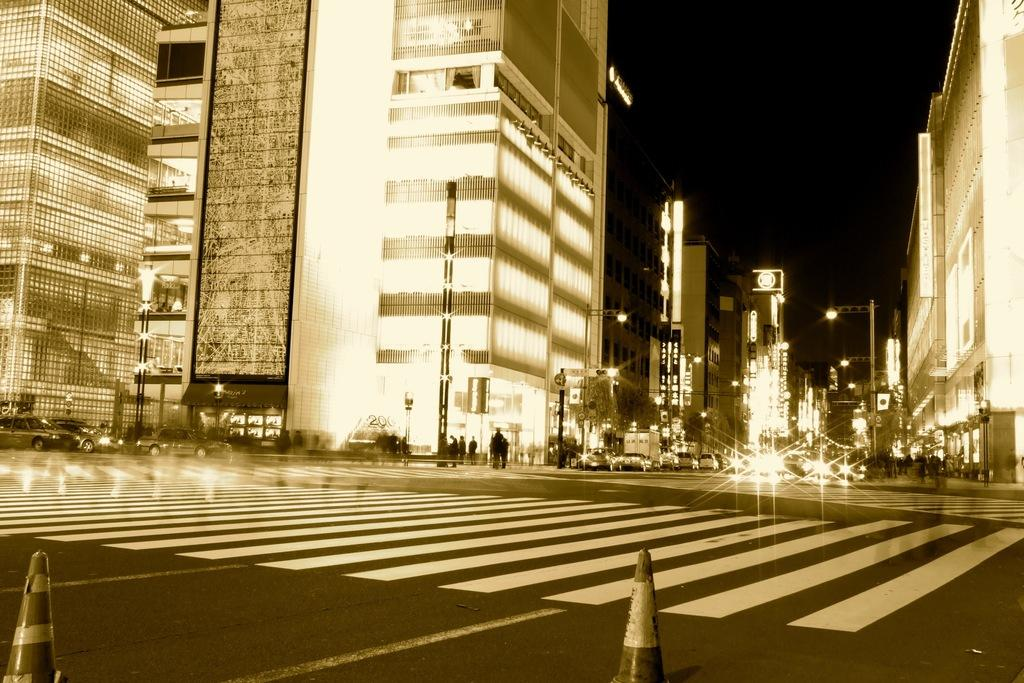What objects are present in the image that are used to control traffic? There are traffic cones in the image. What types of vehicles can be seen in the image? There are vehicles in the image. What is the presence of people on the road in the image suggest? The presence of people on the road in the image suggests that there is some activity or movement happening. What type of structures can be seen in the image? There are buildings in the image. What type of illumination is present in the image? There are lights in the image. How would you describe the overall lighting condition in the image? The background of the image is dark. How many centipedes are crawling on the vehicles in the image? There are no centipedes present in the image; it features traffic cones, vehicles, people, buildings, lights, and a dark background. What type of attack is happening in the image? There is no attack depicted in the image; it shows a scene with traffic cones, vehicles, people, buildings, lights, and a dark background. 